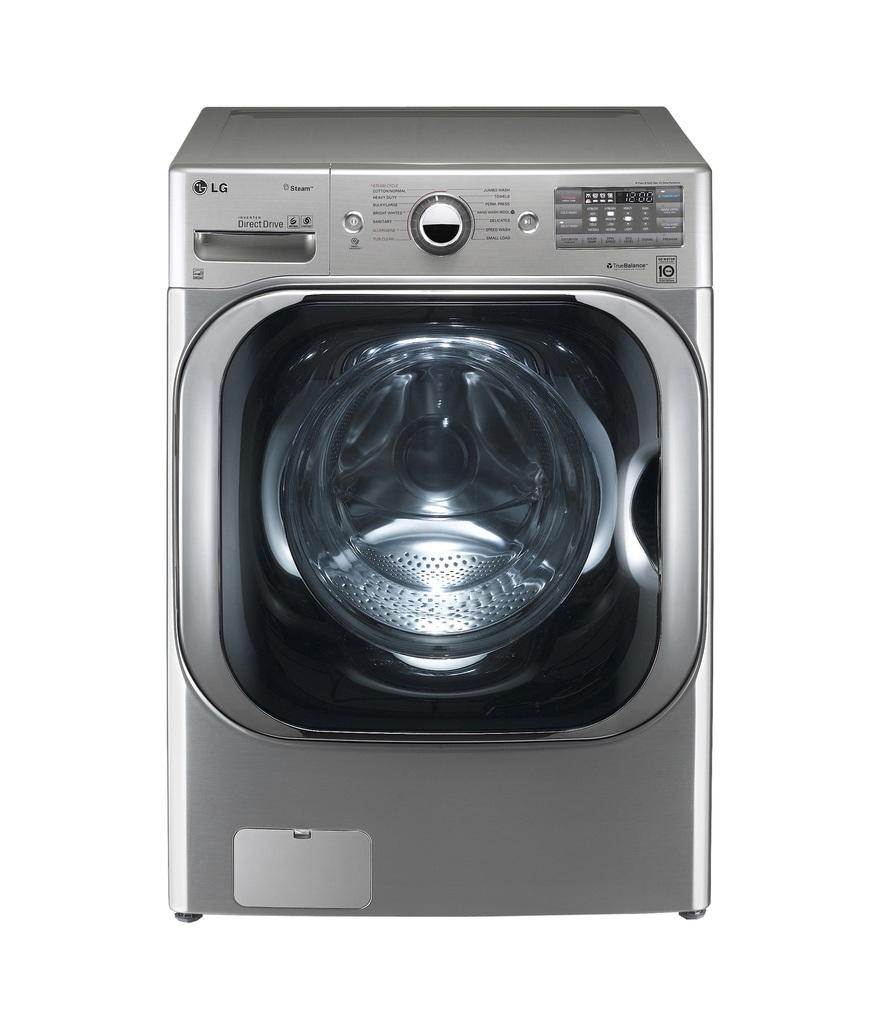What appliance is present in the image? There is a washing machine in the image. Which company manufactures the washing machine? The washing machine is from LG company. Are there any fairies dancing around the washing machine in the image? No, there are no fairies present in the image. What songs are being played by the washing machine in the image? The washing machine does not play songs; it is an appliance for cleaning clothes. 